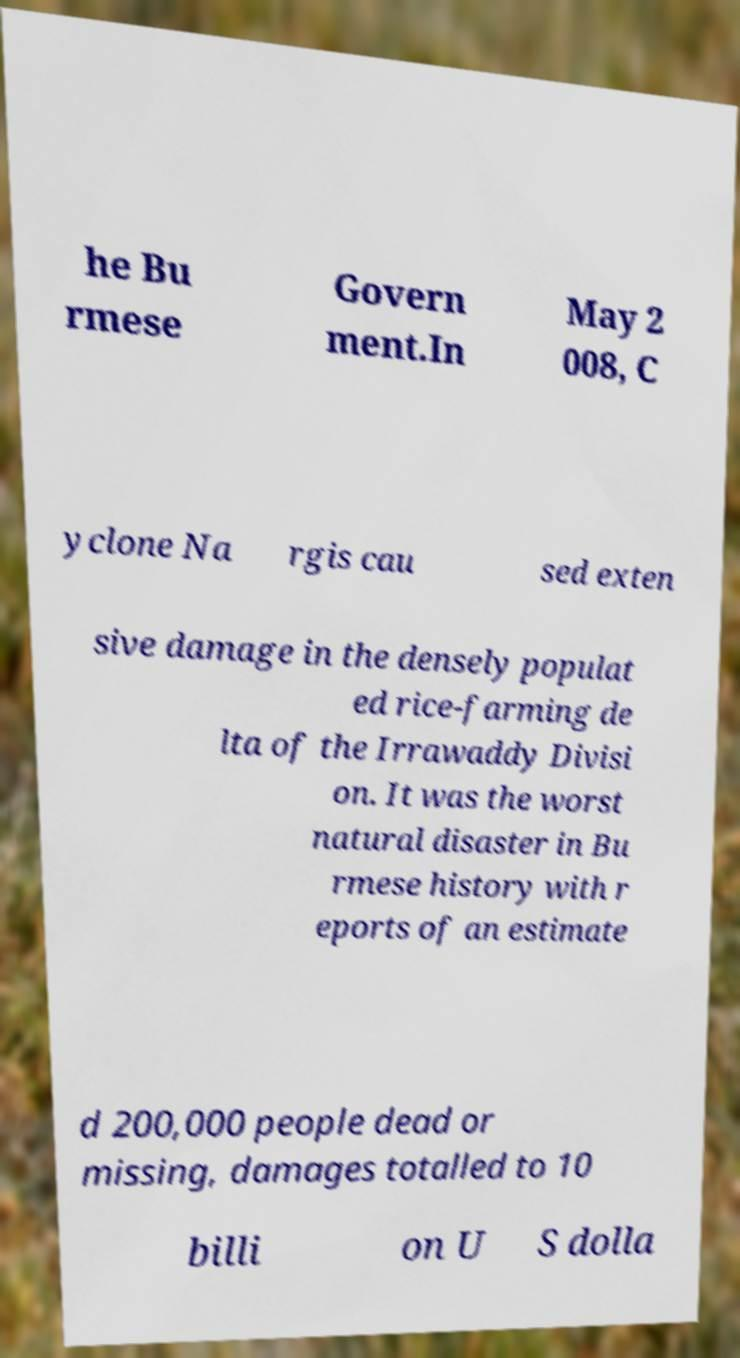There's text embedded in this image that I need extracted. Can you transcribe it verbatim? he Bu rmese Govern ment.In May 2 008, C yclone Na rgis cau sed exten sive damage in the densely populat ed rice-farming de lta of the Irrawaddy Divisi on. It was the worst natural disaster in Bu rmese history with r eports of an estimate d 200,000 people dead or missing, damages totalled to 10 billi on U S dolla 